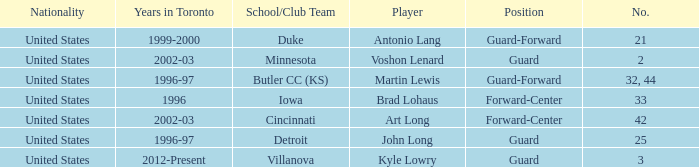Write the full table. {'header': ['Nationality', 'Years in Toronto', 'School/Club Team', 'Player', 'Position', 'No.'], 'rows': [['United States', '1999-2000', 'Duke', 'Antonio Lang', 'Guard-Forward', '21'], ['United States', '2002-03', 'Minnesota', 'Voshon Lenard', 'Guard', '2'], ['United States', '1996-97', 'Butler CC (KS)', 'Martin Lewis', 'Guard-Forward', '32, 44'], ['United States', '1996', 'Iowa', 'Brad Lohaus', 'Forward-Center', '33'], ['United States', '2002-03', 'Cincinnati', 'Art Long', 'Forward-Center', '42'], ['United States', '1996-97', 'Detroit', 'John Long', 'Guard', '25'], ['United States', '2012-Present', 'Villanova', 'Kyle Lowry', 'Guard', '3']]} What player played guard for toronto in 1996-97? John Long. 